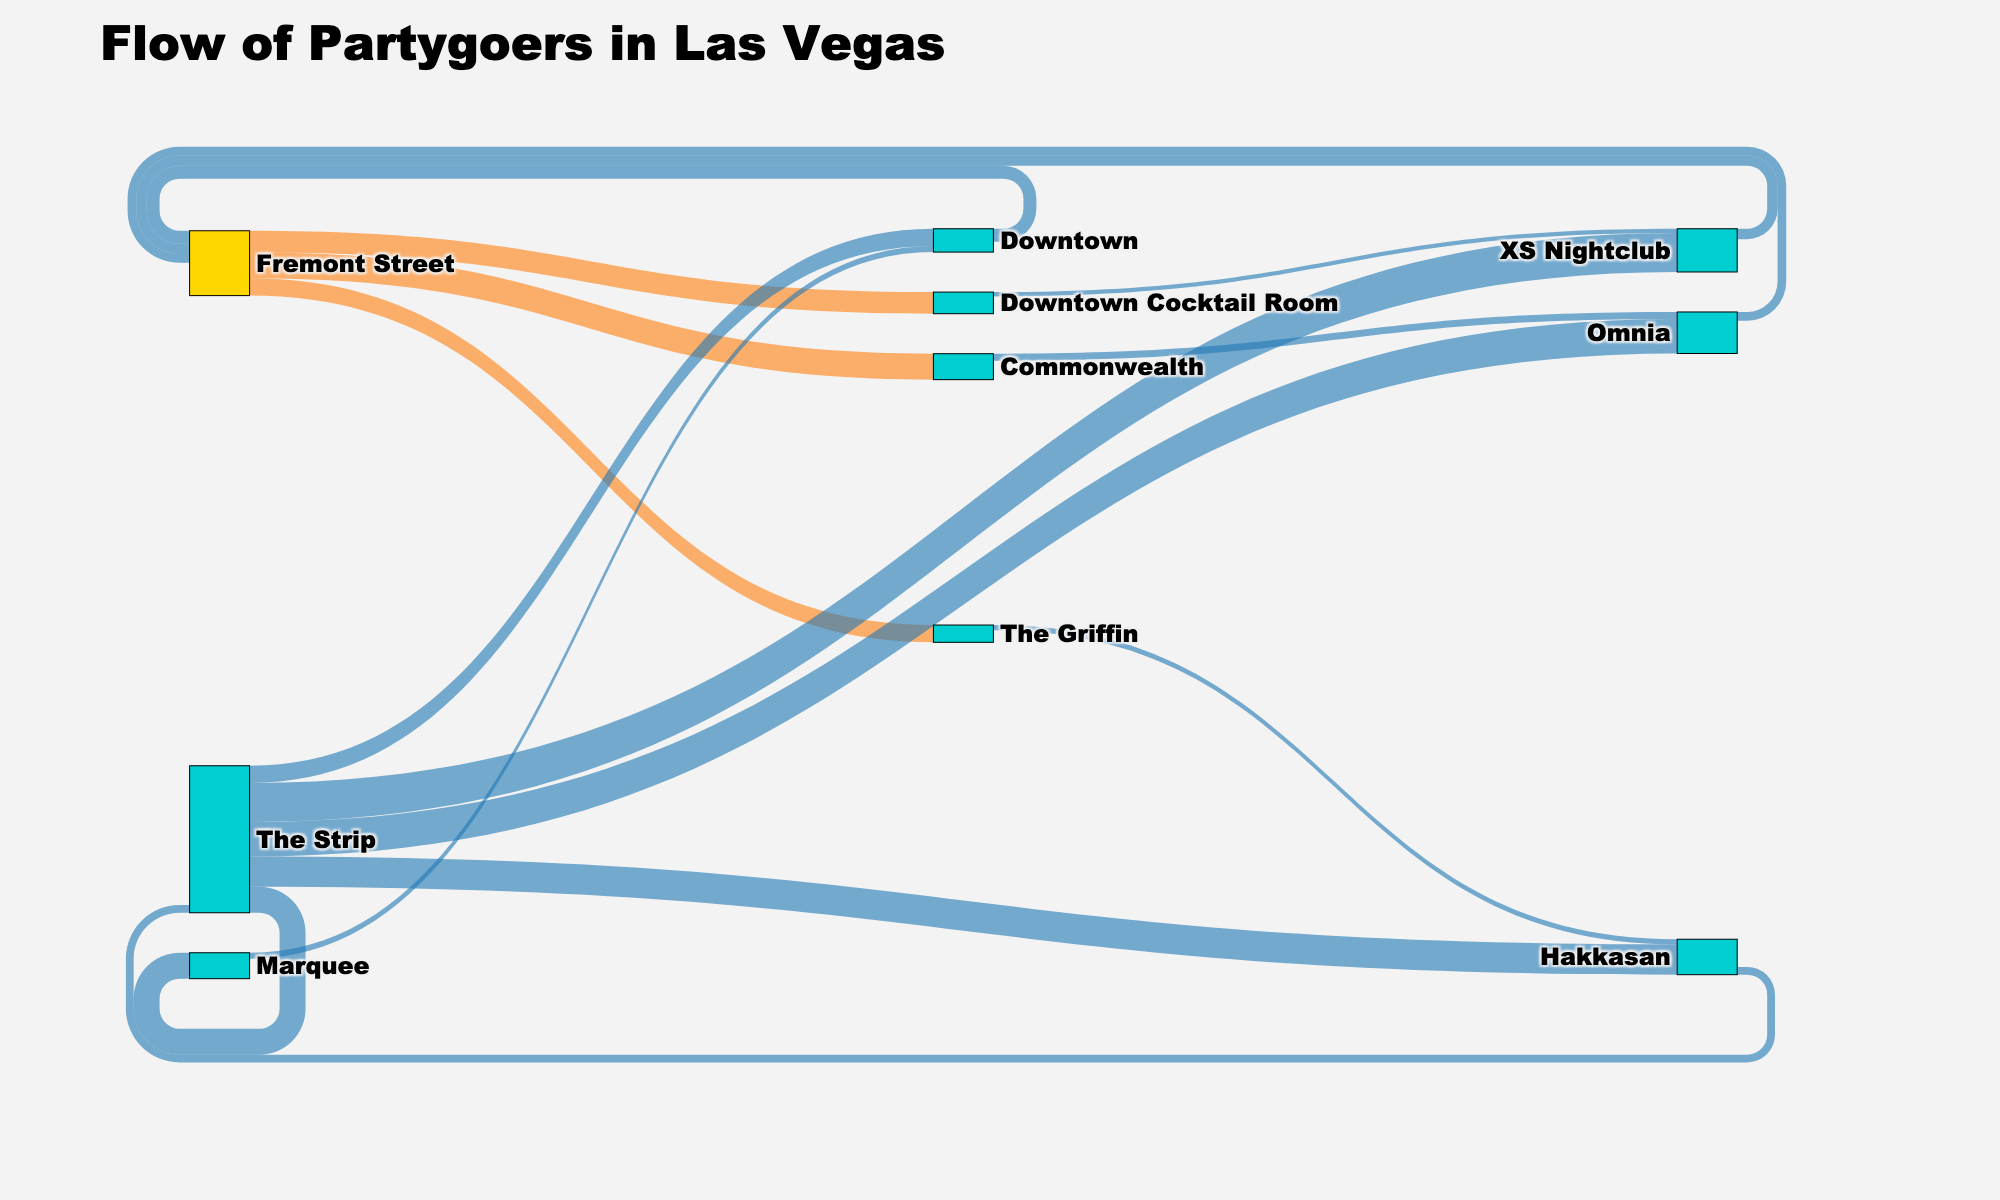Which nightclub on The Strip attracts the most partygoers? The figure shows that XS Nightclub has the largest flow of partygoers from The Strip with 4500 people.
Answer: XS Nightclub How many people move from Omnia back to Fremont Street? The Sankey diagram shows a flow from Omnia to Fremont Street, quantified as 1000 people.
Answer: 1000 Which district serves as both a starting and ending node throughout the night? Fremont Street has partygoers both starting and ending their night there as indicated by multiple inflows and outflows in the diagram.
Answer: Fremont Street From Downtown Cocktail Room, where do the most partygoers head to next? The largest single flow out of Downtown Cocktail Room moves to XS Nightclub, with a value of 500.
Answer: XS Nightclub How many total partygoers start their night on Fremont Street? Adding up the values leading out of Fremont Street: 2500 (Downtown Cocktail Room) + 3000 (Commonwealth) + 2000 (The Griffin) equals 7500.
Answer: 7500 Compare the number of partygoers moving from Omnia and XS Nightclub back to Fremont Street. Omnia sends 1000 partygoers to Fremont Street, while XS Nightclub sends 1200. XS Nightclub's flow is greater.
Answer: XS Nightclub Calculate the total number of partygoers moving between The Strip and Fremont Street in both directions. Summing the values: 4000 (Omnia) + 4500 (XS Nightclub) + 3500 (Hakkasan) + 3000 (Marquee) for outbound (The Strip to Fremont Street) equals 15000; 1000 (Omnia) + 1200 (XS Nightclub) + 900 (Hakkasan) for inbound (Fremont Street to The Strip) equals 3100. Therefore, the total is 15000 + 3100.
Answer: 18100 